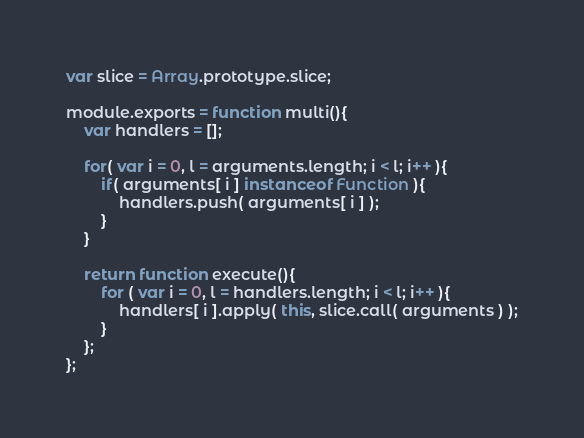Convert code to text. <code><loc_0><loc_0><loc_500><loc_500><_JavaScript_>var slice = Array.prototype.slice;

module.exports = function multi(){
	var handlers = [];

	for( var i = 0, l = arguments.length; i < l; i++ ){
		if( arguments[ i ] instanceof Function ){
			handlers.push( arguments[ i ] );
		}
	}

	return function execute(){
		for ( var i = 0, l = handlers.length; i < l; i++ ){
			handlers[ i ].apply( this, slice.call( arguments ) );
		}
	};
};
</code> 